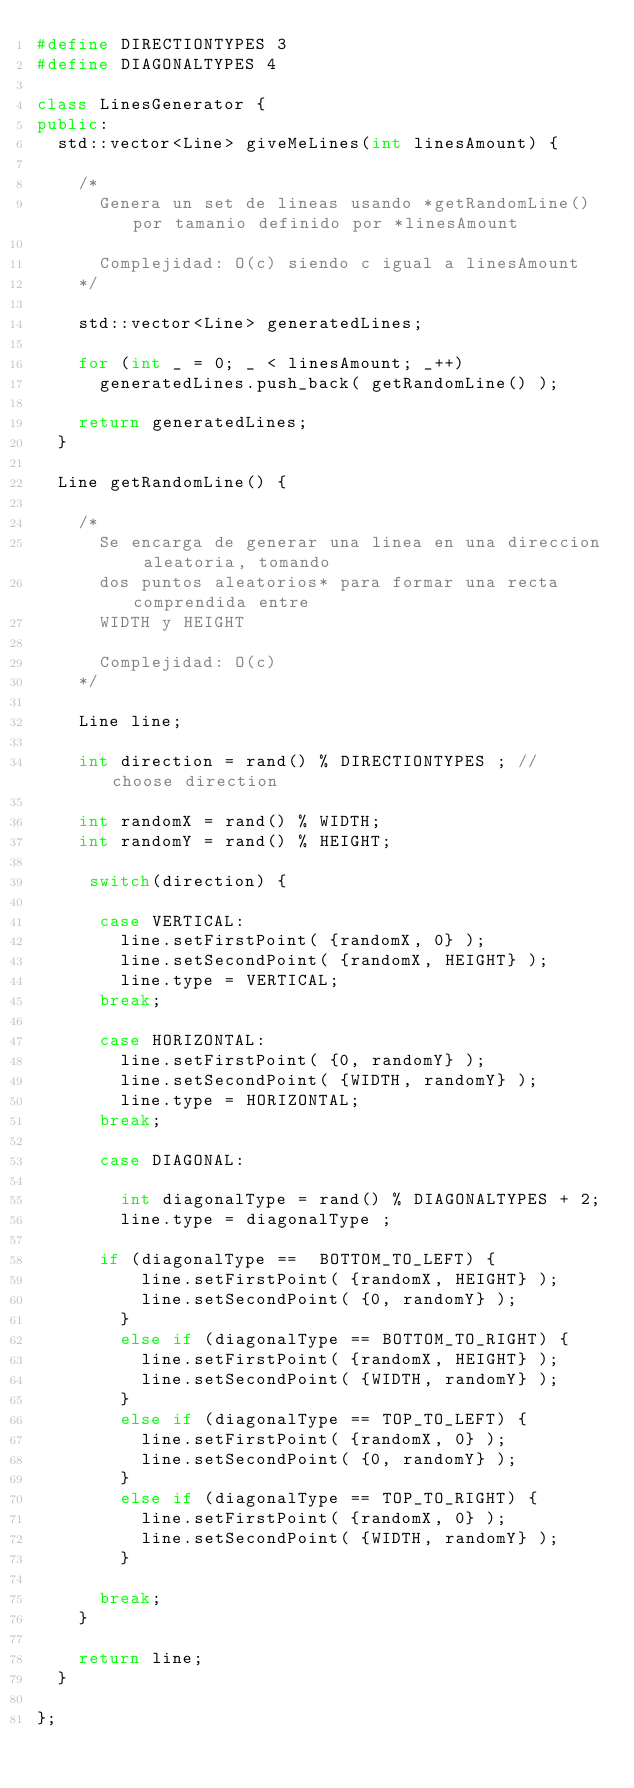Convert code to text. <code><loc_0><loc_0><loc_500><loc_500><_C++_>#define DIRECTIONTYPES 3
#define DIAGONALTYPES 4

class LinesGenerator {
public:
	std::vector<Line> giveMeLines(int linesAmount) {

		/*
			Genera un set de lineas usando *getRandomLine() por tamanio definido por *linesAmount

			Complejidad: O(c) siendo c igual a linesAmount 
		*/

		std::vector<Line> generatedLines;	
		
		for (int _ = 0; _ < linesAmount; _++)
			generatedLines.push_back( getRandomLine() );

		return generatedLines;
	}

	Line getRandomLine() {

		/*
			Se encarga de generar una linea en una direccion aleatoria, tomando
			dos puntos aleatorios* para formar una recta comprendida entre
			WIDTH y HEIGHT

			Complejidad: O(c) 
		*/

		Line line;

		int direction = rand() % DIRECTIONTYPES ; // choose direction

		int randomX = rand() % WIDTH;
		int randomY = rand() % HEIGHT;
  
	   switch(direction) {
	  
	    case VERTICAL: 
	    	line.setFirstPoint( {randomX, 0} );
	      line.setSecondPoint( {randomX, HEIGHT} );
	      line.type = VERTICAL;
	    break;

	    case HORIZONTAL: 
	      line.setFirstPoint( {0, randomY} );
	      line.setSecondPoint( {WIDTH, randomY} );
	      line.type = HORIZONTAL;
	    break;

	    case DIAGONAL: 

	    	int diagonalType = rand() % DIAGONALTYPES + 2;
	    	line.type = diagonalType ;
			
			if (diagonalType ==  BOTTOM_TO_LEFT) {
    			line.setFirstPoint( {randomX, HEIGHT} );
      		line.setSecondPoint( {0, randomY} ); 
	     	} 
	     	else if (diagonalType == BOTTOM_TO_RIGHT) {
      		line.setFirstPoint( {randomX, HEIGHT} );
      		line.setSecondPoint( {WIDTH, randomY} );
	      } 
	      else if (diagonalType == TOP_TO_LEFT) {
	      	line.setFirstPoint( {randomX, 0} );
	      	line.setSecondPoint( {0, randomY} );
	      } 
	      else if (diagonalType == TOP_TO_RIGHT) {
	      	line.setFirstPoint( {randomX, 0} );
	      	line.setSecondPoint( {WIDTH, randomY} );
	      }

	    break;
	  }

		return line;
	}

};</code> 